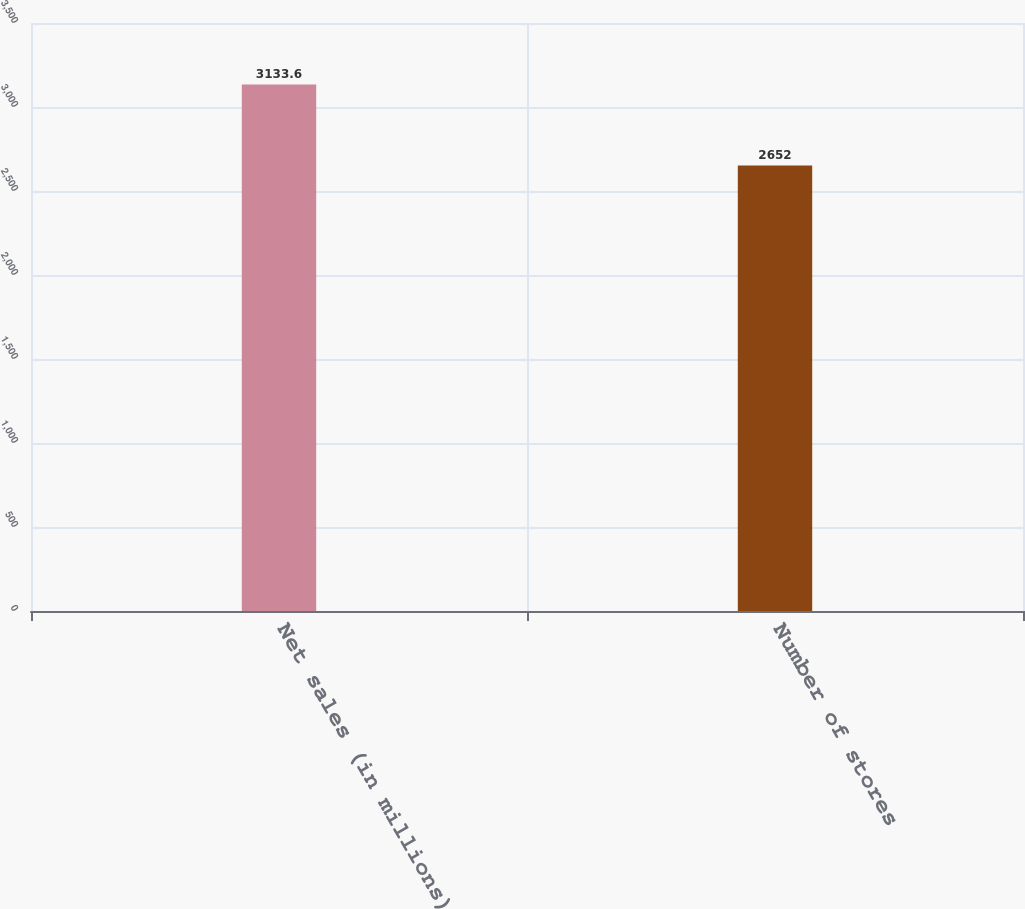Convert chart. <chart><loc_0><loc_0><loc_500><loc_500><bar_chart><fcel>Net sales (in millions)<fcel>Number of stores<nl><fcel>3133.6<fcel>2652<nl></chart> 